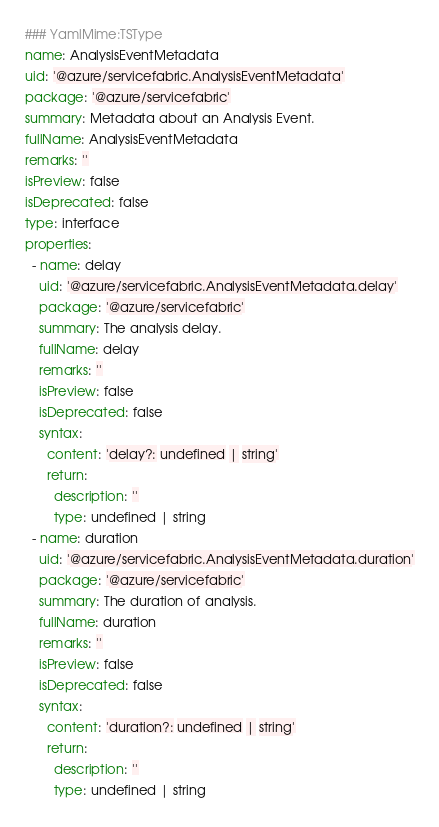Convert code to text. <code><loc_0><loc_0><loc_500><loc_500><_YAML_>### YamlMime:TSType
name: AnalysisEventMetadata
uid: '@azure/servicefabric.AnalysisEventMetadata'
package: '@azure/servicefabric'
summary: Metadata about an Analysis Event.
fullName: AnalysisEventMetadata
remarks: ''
isPreview: false
isDeprecated: false
type: interface
properties:
  - name: delay
    uid: '@azure/servicefabric.AnalysisEventMetadata.delay'
    package: '@azure/servicefabric'
    summary: The analysis delay.
    fullName: delay
    remarks: ''
    isPreview: false
    isDeprecated: false
    syntax:
      content: 'delay?: undefined | string'
      return:
        description: ''
        type: undefined | string
  - name: duration
    uid: '@azure/servicefabric.AnalysisEventMetadata.duration'
    package: '@azure/servicefabric'
    summary: The duration of analysis.
    fullName: duration
    remarks: ''
    isPreview: false
    isDeprecated: false
    syntax:
      content: 'duration?: undefined | string'
      return:
        description: ''
        type: undefined | string
</code> 